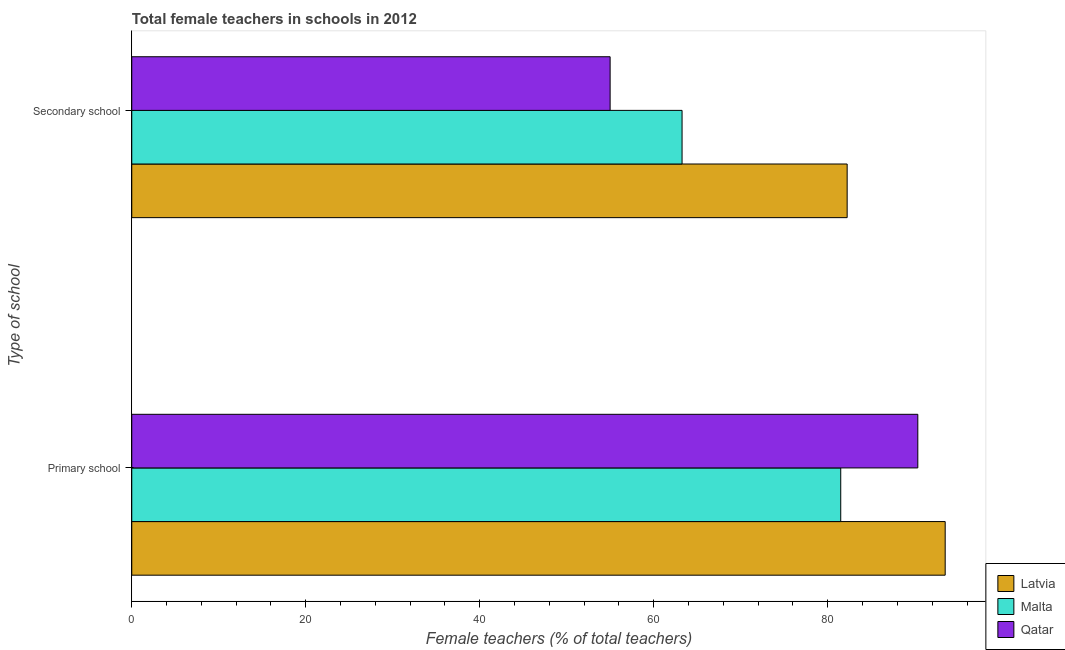How many different coloured bars are there?
Give a very brief answer. 3. How many groups of bars are there?
Provide a succinct answer. 2. Are the number of bars per tick equal to the number of legend labels?
Give a very brief answer. Yes. Are the number of bars on each tick of the Y-axis equal?
Your answer should be compact. Yes. How many bars are there on the 2nd tick from the top?
Your response must be concise. 3. How many bars are there on the 1st tick from the bottom?
Your answer should be very brief. 3. What is the label of the 1st group of bars from the top?
Provide a succinct answer. Secondary school. What is the percentage of female teachers in secondary schools in Latvia?
Your response must be concise. 82.23. Across all countries, what is the maximum percentage of female teachers in primary schools?
Your answer should be very brief. 93.49. Across all countries, what is the minimum percentage of female teachers in secondary schools?
Ensure brevity in your answer.  54.98. In which country was the percentage of female teachers in secondary schools maximum?
Provide a succinct answer. Latvia. In which country was the percentage of female teachers in primary schools minimum?
Your response must be concise. Malta. What is the total percentage of female teachers in secondary schools in the graph?
Your response must be concise. 200.46. What is the difference between the percentage of female teachers in primary schools in Latvia and that in Malta?
Give a very brief answer. 12.01. What is the difference between the percentage of female teachers in secondary schools in Qatar and the percentage of female teachers in primary schools in Malta?
Provide a succinct answer. -26.51. What is the average percentage of female teachers in secondary schools per country?
Provide a succinct answer. 66.82. What is the difference between the percentage of female teachers in primary schools and percentage of female teachers in secondary schools in Latvia?
Your response must be concise. 11.27. What is the ratio of the percentage of female teachers in primary schools in Latvia to that in Qatar?
Offer a very short reply. 1.03. What does the 2nd bar from the top in Primary school represents?
Provide a succinct answer. Malta. What does the 1st bar from the bottom in Secondary school represents?
Your answer should be very brief. Latvia. What is the difference between two consecutive major ticks on the X-axis?
Provide a succinct answer. 20. Are the values on the major ticks of X-axis written in scientific E-notation?
Provide a short and direct response. No. Does the graph contain grids?
Offer a very short reply. No. Where does the legend appear in the graph?
Give a very brief answer. Bottom right. How are the legend labels stacked?
Your answer should be compact. Vertical. What is the title of the graph?
Ensure brevity in your answer.  Total female teachers in schools in 2012. What is the label or title of the X-axis?
Offer a terse response. Female teachers (% of total teachers). What is the label or title of the Y-axis?
Keep it short and to the point. Type of school. What is the Female teachers (% of total teachers) of Latvia in Primary school?
Your answer should be very brief. 93.49. What is the Female teachers (% of total teachers) in Malta in Primary school?
Your answer should be compact. 81.49. What is the Female teachers (% of total teachers) in Qatar in Primary school?
Offer a very short reply. 90.35. What is the Female teachers (% of total teachers) in Latvia in Secondary school?
Offer a terse response. 82.23. What is the Female teachers (% of total teachers) in Malta in Secondary school?
Keep it short and to the point. 63.25. What is the Female teachers (% of total teachers) of Qatar in Secondary school?
Your response must be concise. 54.98. Across all Type of school, what is the maximum Female teachers (% of total teachers) in Latvia?
Your answer should be compact. 93.49. Across all Type of school, what is the maximum Female teachers (% of total teachers) in Malta?
Your answer should be compact. 81.49. Across all Type of school, what is the maximum Female teachers (% of total teachers) in Qatar?
Make the answer very short. 90.35. Across all Type of school, what is the minimum Female teachers (% of total teachers) of Latvia?
Your answer should be compact. 82.23. Across all Type of school, what is the minimum Female teachers (% of total teachers) in Malta?
Offer a terse response. 63.25. Across all Type of school, what is the minimum Female teachers (% of total teachers) of Qatar?
Make the answer very short. 54.98. What is the total Female teachers (% of total teachers) in Latvia in the graph?
Ensure brevity in your answer.  175.72. What is the total Female teachers (% of total teachers) in Malta in the graph?
Provide a succinct answer. 144.74. What is the total Female teachers (% of total teachers) of Qatar in the graph?
Ensure brevity in your answer.  145.33. What is the difference between the Female teachers (% of total teachers) of Latvia in Primary school and that in Secondary school?
Provide a succinct answer. 11.27. What is the difference between the Female teachers (% of total teachers) in Malta in Primary school and that in Secondary school?
Provide a short and direct response. 18.24. What is the difference between the Female teachers (% of total teachers) of Qatar in Primary school and that in Secondary school?
Offer a very short reply. 35.36. What is the difference between the Female teachers (% of total teachers) of Latvia in Primary school and the Female teachers (% of total teachers) of Malta in Secondary school?
Offer a very short reply. 30.24. What is the difference between the Female teachers (% of total teachers) in Latvia in Primary school and the Female teachers (% of total teachers) in Qatar in Secondary school?
Ensure brevity in your answer.  38.51. What is the difference between the Female teachers (% of total teachers) in Malta in Primary school and the Female teachers (% of total teachers) in Qatar in Secondary school?
Your response must be concise. 26.51. What is the average Female teachers (% of total teachers) in Latvia per Type of school?
Your answer should be compact. 87.86. What is the average Female teachers (% of total teachers) of Malta per Type of school?
Offer a terse response. 72.37. What is the average Female teachers (% of total teachers) in Qatar per Type of school?
Your answer should be compact. 72.66. What is the difference between the Female teachers (% of total teachers) of Latvia and Female teachers (% of total teachers) of Malta in Primary school?
Your response must be concise. 12.01. What is the difference between the Female teachers (% of total teachers) of Latvia and Female teachers (% of total teachers) of Qatar in Primary school?
Your response must be concise. 3.15. What is the difference between the Female teachers (% of total teachers) in Malta and Female teachers (% of total teachers) in Qatar in Primary school?
Keep it short and to the point. -8.86. What is the difference between the Female teachers (% of total teachers) in Latvia and Female teachers (% of total teachers) in Malta in Secondary school?
Your answer should be compact. 18.97. What is the difference between the Female teachers (% of total teachers) in Latvia and Female teachers (% of total teachers) in Qatar in Secondary school?
Your answer should be compact. 27.24. What is the difference between the Female teachers (% of total teachers) in Malta and Female teachers (% of total teachers) in Qatar in Secondary school?
Offer a very short reply. 8.27. What is the ratio of the Female teachers (% of total teachers) in Latvia in Primary school to that in Secondary school?
Your response must be concise. 1.14. What is the ratio of the Female teachers (% of total teachers) in Malta in Primary school to that in Secondary school?
Keep it short and to the point. 1.29. What is the ratio of the Female teachers (% of total teachers) in Qatar in Primary school to that in Secondary school?
Keep it short and to the point. 1.64. What is the difference between the highest and the second highest Female teachers (% of total teachers) in Latvia?
Offer a very short reply. 11.27. What is the difference between the highest and the second highest Female teachers (% of total teachers) of Malta?
Your answer should be very brief. 18.24. What is the difference between the highest and the second highest Female teachers (% of total teachers) in Qatar?
Make the answer very short. 35.36. What is the difference between the highest and the lowest Female teachers (% of total teachers) of Latvia?
Your answer should be compact. 11.27. What is the difference between the highest and the lowest Female teachers (% of total teachers) in Malta?
Offer a very short reply. 18.24. What is the difference between the highest and the lowest Female teachers (% of total teachers) in Qatar?
Provide a short and direct response. 35.36. 